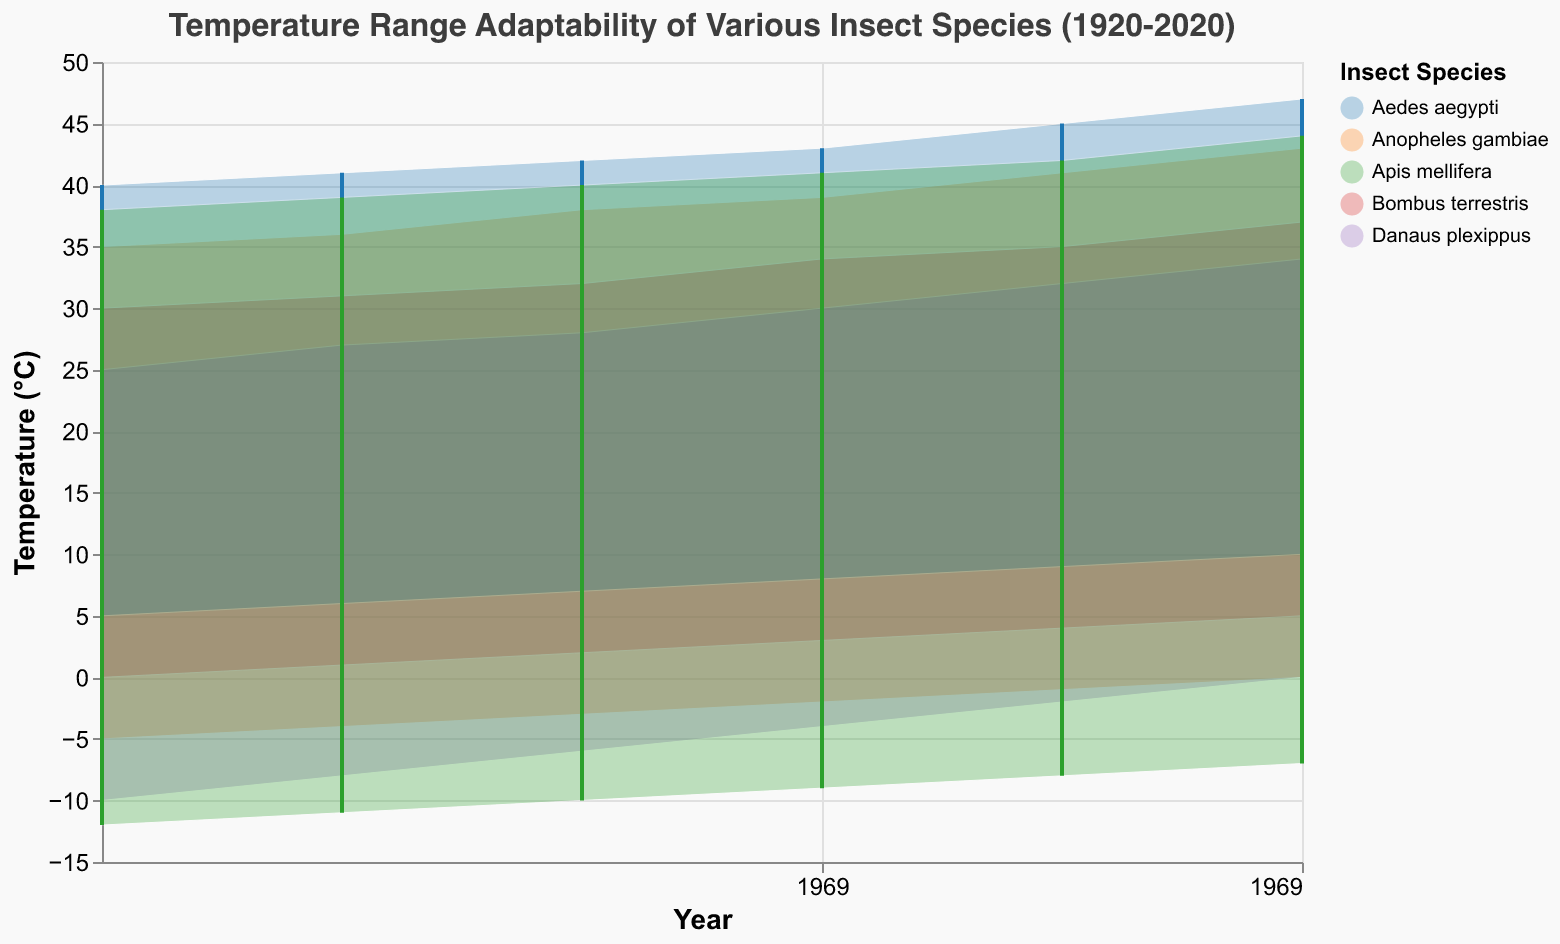Which species shows the biggest increase in their maximum temperature adaptability from 1920 to 2020? To determine this, compare the maximum temperatures for each species in 1920 and 2020 and calculate the increase for each. Anopheles gambiae increases from 35 to 43 (8°C), Bombus terrestris from 30 to 37 (7°C), Danaus plexippus from 25 to 34 (9°C), Aedes aegypti from 40 to 47 (7°C), and Apis mellifera from 38 to 44 (6°C).
Answer: Danaus plexippus Which species had the lowest minimum temperature adaptability in 2020? Look at the minimum temperature values in 2020 for each species. Anopheles gambiae is at 0°C, Bombus terrestris is at 5°C, Danaus plexippus is at 0°C, Aedes aegypti is at 10°C, and Apis mellifera is at -7°C.
Answer: Apis mellifera What is the average maximum temperature adaptability for Apis mellifera across all years shown? Sum the maximum temperatures for Apis mellifera across the years 1920, 1940, 1960, 1980, 2000, and 2020 (38, 39, 40, 41, 42, 44), and divide by the number of years (6). (38 + 39 + 40 + 41 + 42 + 44) / 6 = 40.67°C.
Answer: 40.67°C During which period did Bombus terrestris experience the greatest increase in maximum temperature adaptability? Compare the increments between each successive two decades for Bombus terrestris. For instance, 1920-1940 (30-31 = 1°C), 1940-1960 (31-32 = 1°C), 1960-1980 (32-34 = 2°C), 1980-2000 (34-35 = 1°C), 2000-2020 (35-37 = 2°C). Find the largest increase.
Answer: 1960-1980 and 2000-2020 How does the temperature range adaptability of Aedes aegypti in 2020 compare to that of Bombus terrestris in 2020? Compare the minimum and maximum temperatures for both species in 2020. Aedes aegypti ranges from 10°C to 47°C, a range of 37°C. Bombus terrestris ranges from 5°C to 37°C, a range of 32°C.
Answer: Aedes aegypti has a wider range by 5°C Which year had the most similar temperature range adaptability between Anopheles gambiae and Danaus plexippus? Calculate the temperature ranges (Maximum - Minimum) for Anopheles gambiae and Danaus plexippus across the years and identify the year with the closest values. For instance, 1920: Anopheles gambiae (35 - (-5) = 40°C), Danaus plexippus (25 - (-10) = 35°C), and so on.
Answer: 2020 What is the trend in minimum temperature adaptability for Danaus plexippus from 1920 to 2020? Plot the minimum temperature values for Danaus plexippus across the years (1920, 1940, 1960, 1980, 2000, and 2020) and observe the change. From -10 to 0, the trend is an increase.
Answer: Increasing 